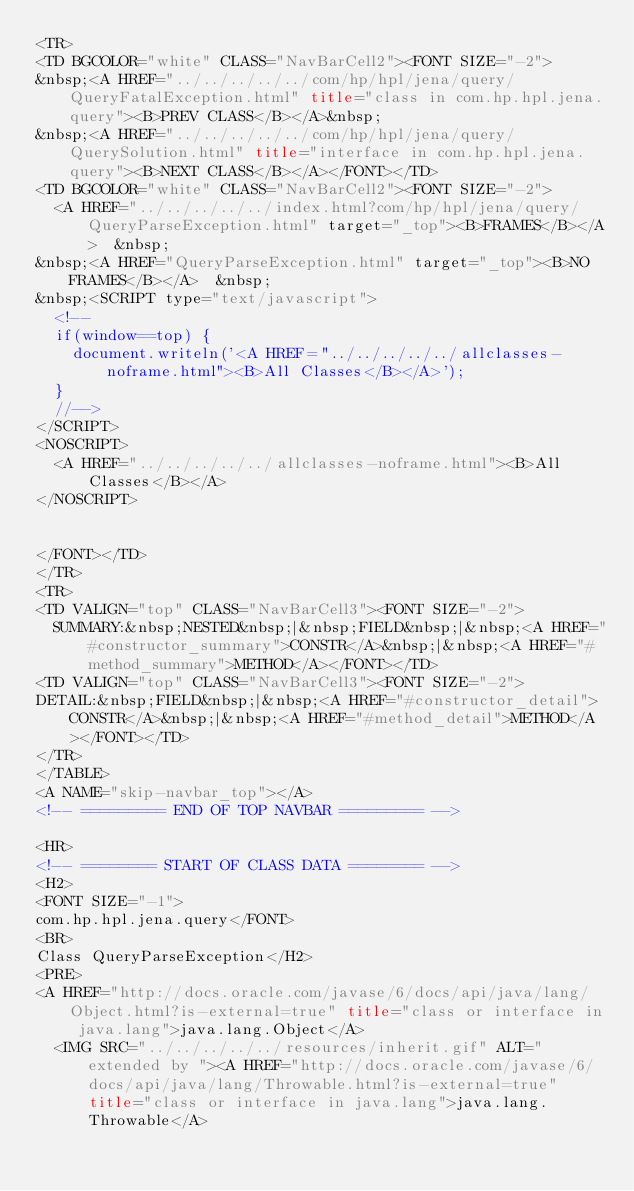Convert code to text. <code><loc_0><loc_0><loc_500><loc_500><_HTML_><TR>
<TD BGCOLOR="white" CLASS="NavBarCell2"><FONT SIZE="-2">
&nbsp;<A HREF="../../../../../com/hp/hpl/jena/query/QueryFatalException.html" title="class in com.hp.hpl.jena.query"><B>PREV CLASS</B></A>&nbsp;
&nbsp;<A HREF="../../../../../com/hp/hpl/jena/query/QuerySolution.html" title="interface in com.hp.hpl.jena.query"><B>NEXT CLASS</B></A></FONT></TD>
<TD BGCOLOR="white" CLASS="NavBarCell2"><FONT SIZE="-2">
  <A HREF="../../../../../index.html?com/hp/hpl/jena/query/QueryParseException.html" target="_top"><B>FRAMES</B></A>  &nbsp;
&nbsp;<A HREF="QueryParseException.html" target="_top"><B>NO FRAMES</B></A>  &nbsp;
&nbsp;<SCRIPT type="text/javascript">
  <!--
  if(window==top) {
    document.writeln('<A HREF="../../../../../allclasses-noframe.html"><B>All Classes</B></A>');
  }
  //-->
</SCRIPT>
<NOSCRIPT>
  <A HREF="../../../../../allclasses-noframe.html"><B>All Classes</B></A>
</NOSCRIPT>


</FONT></TD>
</TR>
<TR>
<TD VALIGN="top" CLASS="NavBarCell3"><FONT SIZE="-2">
  SUMMARY:&nbsp;NESTED&nbsp;|&nbsp;FIELD&nbsp;|&nbsp;<A HREF="#constructor_summary">CONSTR</A>&nbsp;|&nbsp;<A HREF="#method_summary">METHOD</A></FONT></TD>
<TD VALIGN="top" CLASS="NavBarCell3"><FONT SIZE="-2">
DETAIL:&nbsp;FIELD&nbsp;|&nbsp;<A HREF="#constructor_detail">CONSTR</A>&nbsp;|&nbsp;<A HREF="#method_detail">METHOD</A></FONT></TD>
</TR>
</TABLE>
<A NAME="skip-navbar_top"></A>
<!-- ========= END OF TOP NAVBAR ========= -->

<HR>
<!-- ======== START OF CLASS DATA ======== -->
<H2>
<FONT SIZE="-1">
com.hp.hpl.jena.query</FONT>
<BR>
Class QueryParseException</H2>
<PRE>
<A HREF="http://docs.oracle.com/javase/6/docs/api/java/lang/Object.html?is-external=true" title="class or interface in java.lang">java.lang.Object</A>
  <IMG SRC="../../../../../resources/inherit.gif" ALT="extended by "><A HREF="http://docs.oracle.com/javase/6/docs/api/java/lang/Throwable.html?is-external=true" title="class or interface in java.lang">java.lang.Throwable</A></code> 